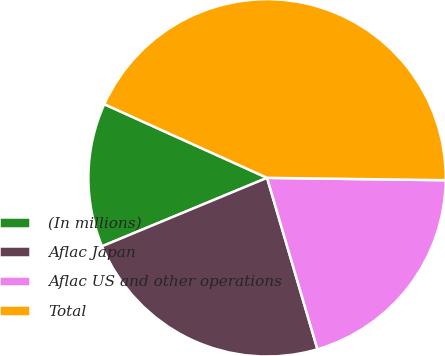Convert chart to OTSL. <chart><loc_0><loc_0><loc_500><loc_500><pie_chart><fcel>(In millions)<fcel>Aflac Japan<fcel>Aflac US and other operations<fcel>Total<nl><fcel>13.02%<fcel>23.29%<fcel>20.24%<fcel>43.45%<nl></chart> 